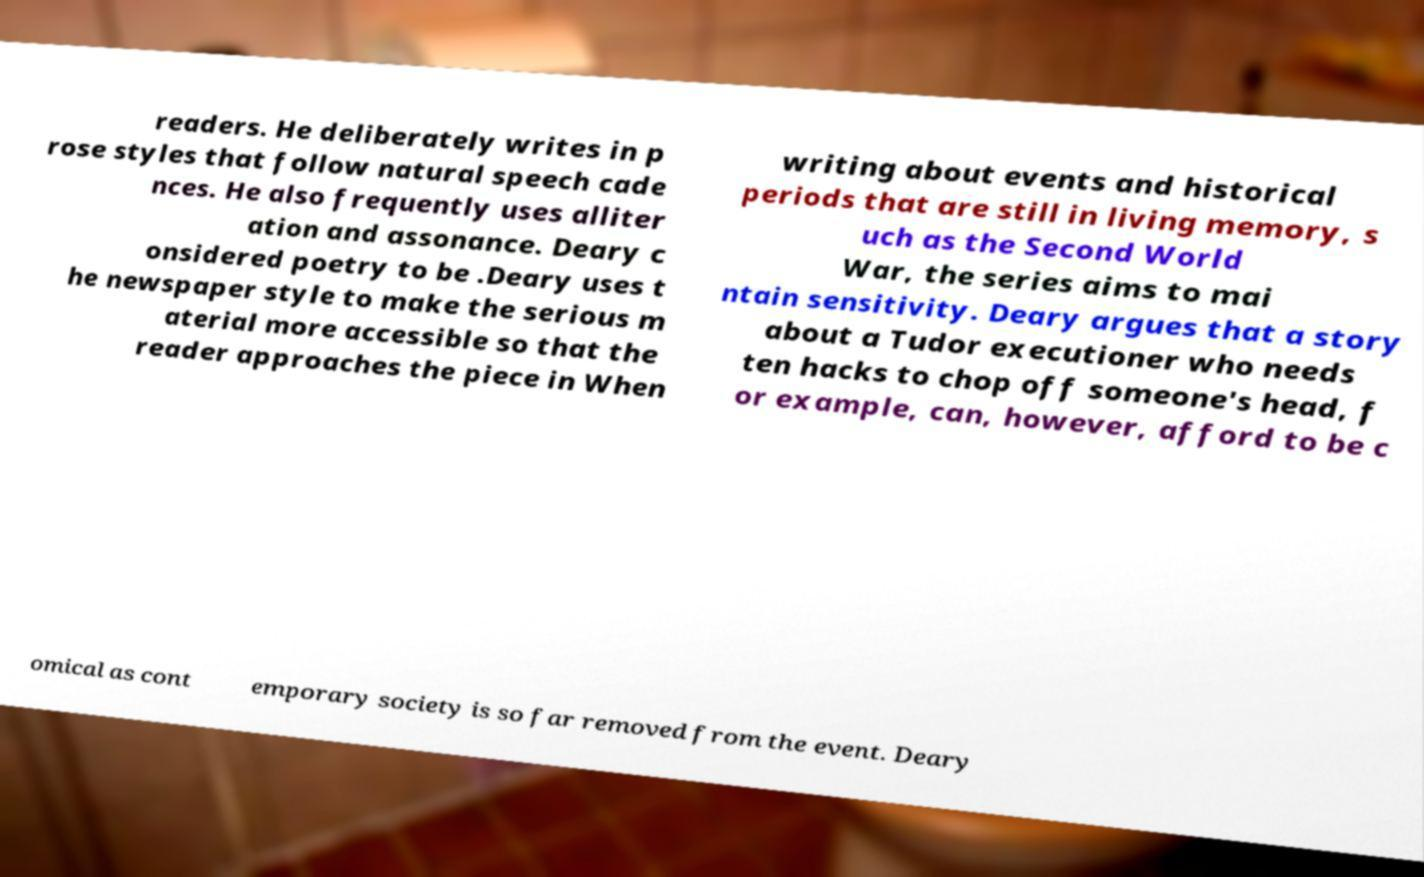Can you accurately transcribe the text from the provided image for me? readers. He deliberately writes in p rose styles that follow natural speech cade nces. He also frequently uses alliter ation and assonance. Deary c onsidered poetry to be .Deary uses t he newspaper style to make the serious m aterial more accessible so that the reader approaches the piece in When writing about events and historical periods that are still in living memory, s uch as the Second World War, the series aims to mai ntain sensitivity. Deary argues that a story about a Tudor executioner who needs ten hacks to chop off someone's head, f or example, can, however, afford to be c omical as cont emporary society is so far removed from the event. Deary 